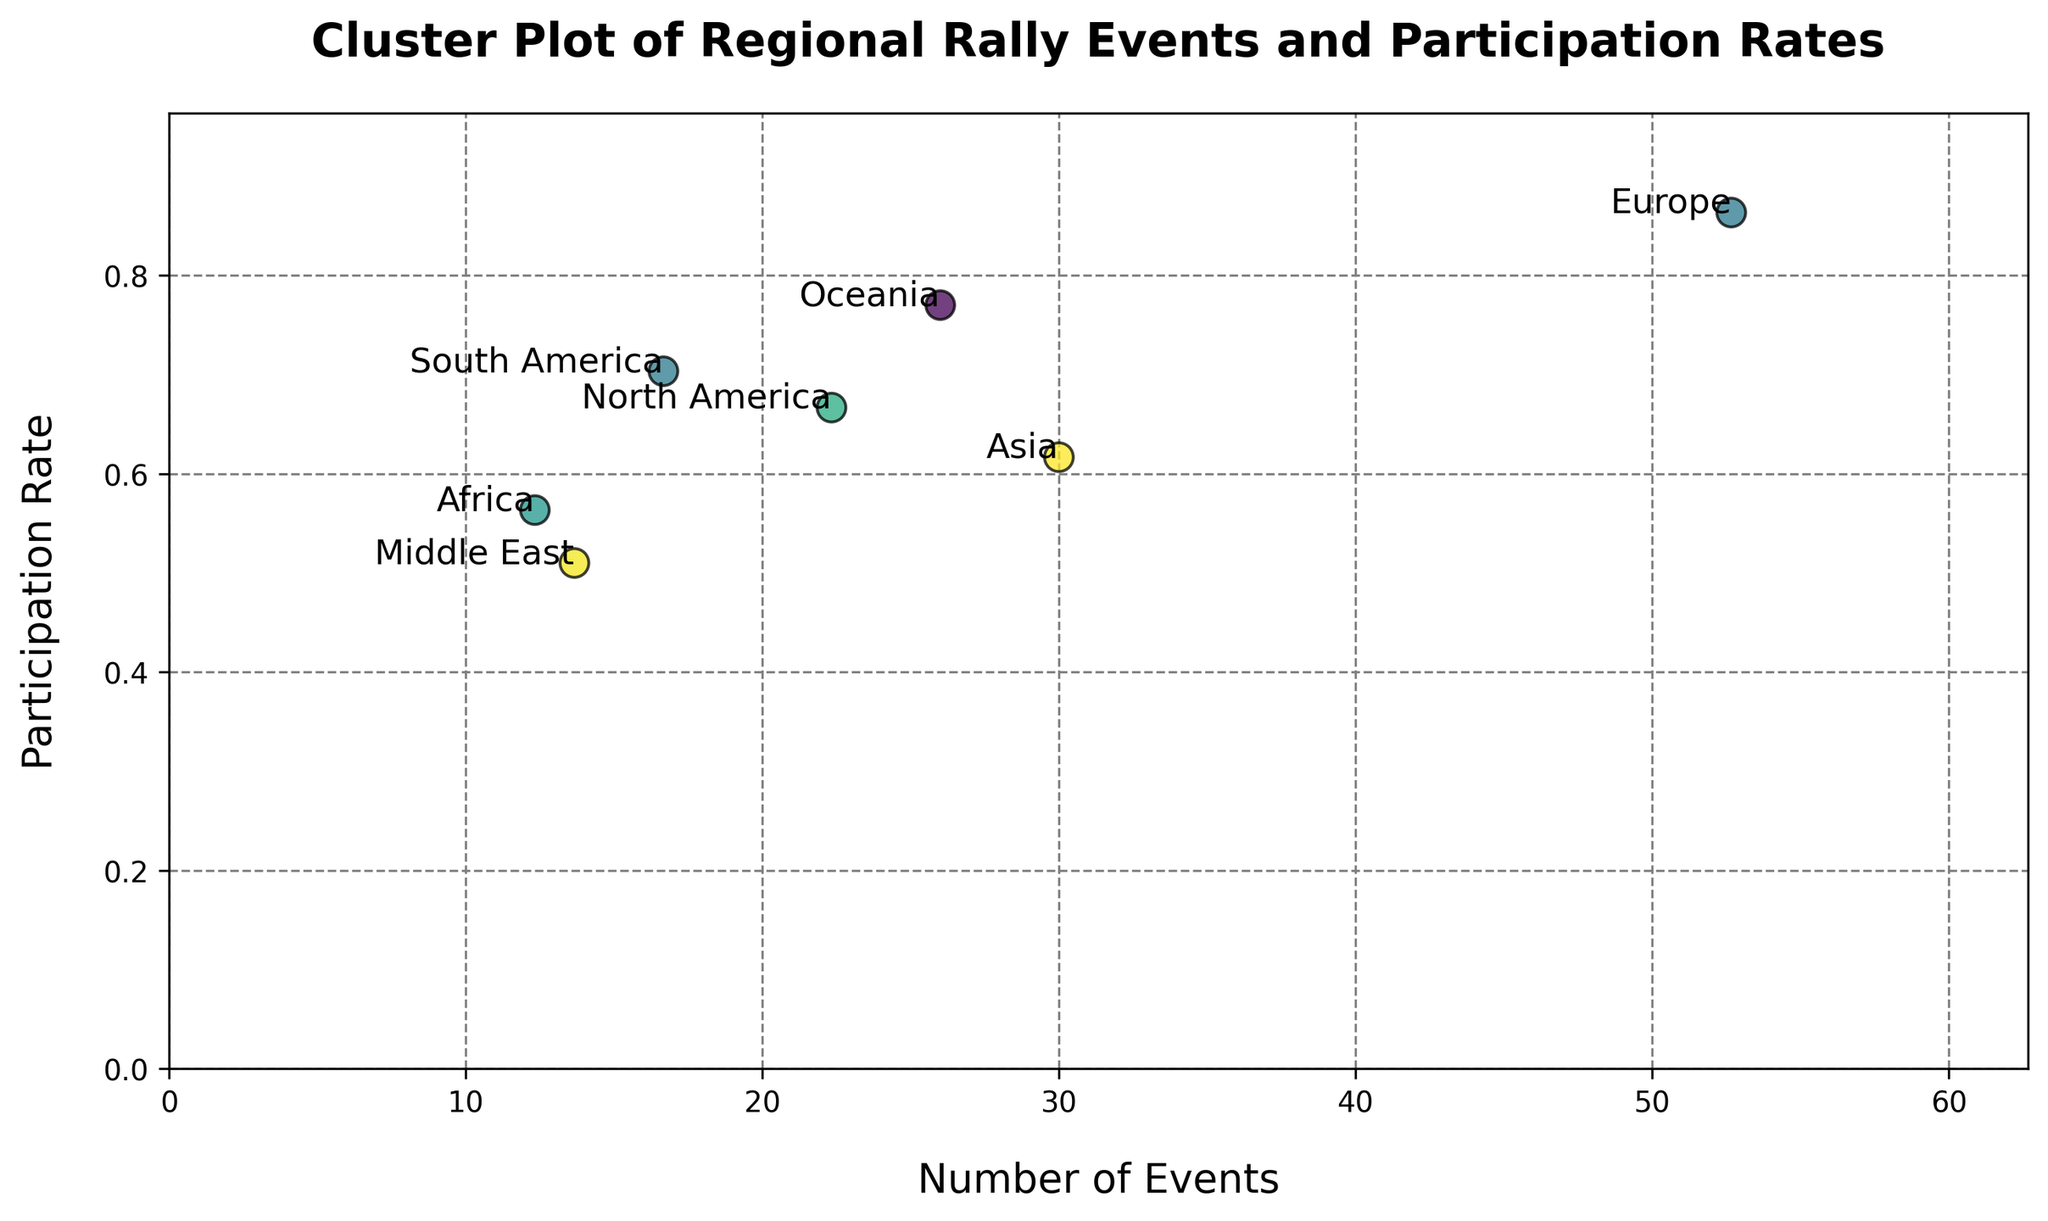Which region has the highest participation rate? By looking at the y-axis (Participation Rate) of the plot, you need to find the point that is the highest on the y-axis. Annotate the corresponding region.
Answer: Europe Which region has the fewest number of events? By looking at the x-axis (Number of Events) of the plot, you need to find the point that is the furthest to the left on the x-axis. Annotate the corresponding region.
Answer: Africa What are the mean number of events and participation rate for Europe? Europe's data points are {'Number_of_Events': [50, 55, 53], 'Participation_Rate': [0.85, 0.88, 0.86]}. Calculate the average for both attributes. (50 + 55 + 53) / 3 = 52.67 and (0.85 + 0.88 + 0.86) / 3 = 0.863.
Answer: 52.67 and 0.863 Is Europe’s participation rate higher than Oceania’s? Compare the y-axis (Participation Rate) location of Europe and Oceania. Europe is around 0.86-0.88, while Oceania is around 0.75-0.79.
Answer: Yes Which region has the second-highest number of events? Identify the region that has the second highest point on the x-axis (Number of Events). The highest is Europe. The second highest point corresponds to Asia.
Answer: Asia What's the difference between the number of events in North America and South America? Look at the x-axis (Number of Events) locations for North America and South America. The average number of events for North America is about 22 and for South America is about 17. Compute the difference (22 - 17).
Answer: 5 Which region has the lowest participation rate? By observing the closest point to 0 on the y-axis (Participation Rate), annotate the corresponding region. The region that has the lowest point is the Middle East, around 0.50-0.52.
Answer: Middle East Do Asia and Africa have closer participation rates compared to their number of events? Look at the y-axis (Participation Rate) and x-axis (Number of Events) for both regions. Asia (0.60-0.63) and Africa (0.55-0.58) have close participation rates, whereas their number of events (Asia: 28-32, Africa:10-14) have a larger difference.
Answer: Yes 